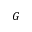Convert formula to latex. <formula><loc_0><loc_0><loc_500><loc_500>G</formula> 